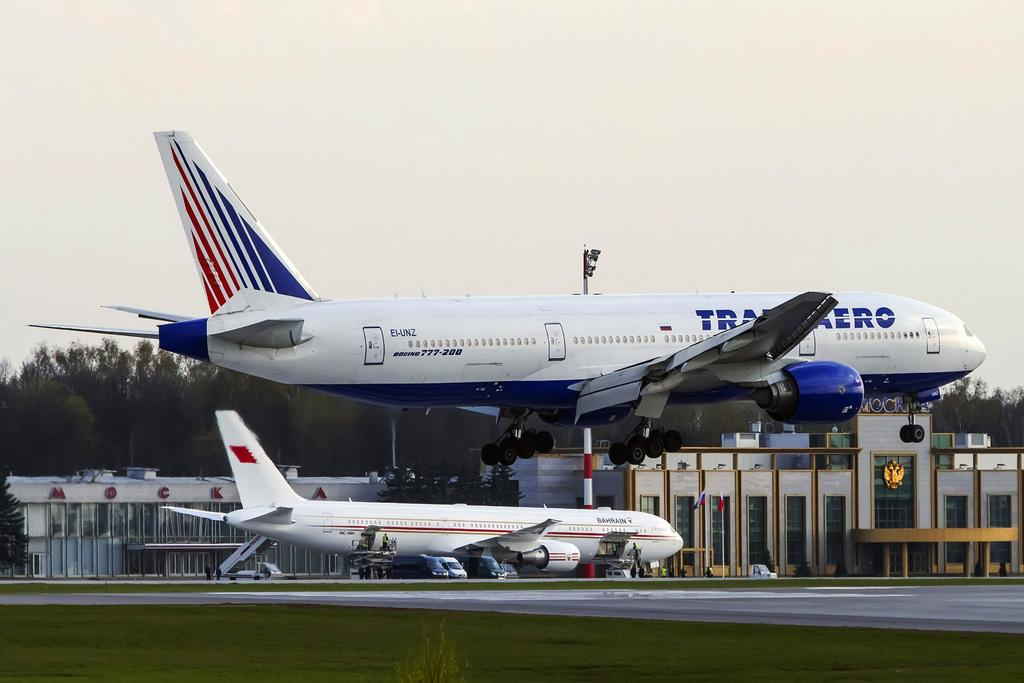<image>
Summarize the visual content of the image. A huge Boeing 777-200 is just lifting off from the runway. 